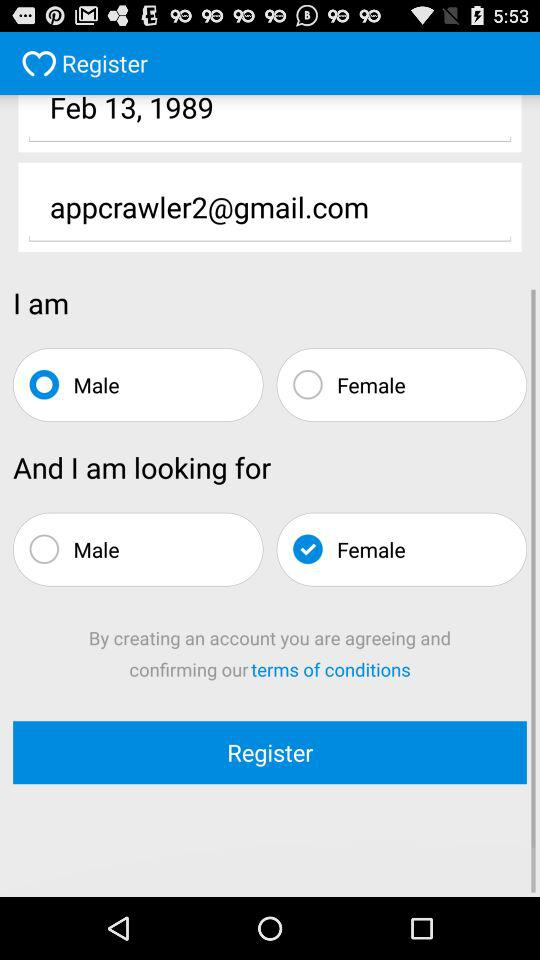What is the website to access? The website is "Facebook". 